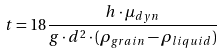Convert formula to latex. <formula><loc_0><loc_0><loc_500><loc_500>t = 1 8 \frac { h \cdot \mu _ { d y n } } { g \cdot d ^ { 2 } \cdot ( \rho _ { g r a i n } - \rho _ { l i q u i d } ) }</formula> 